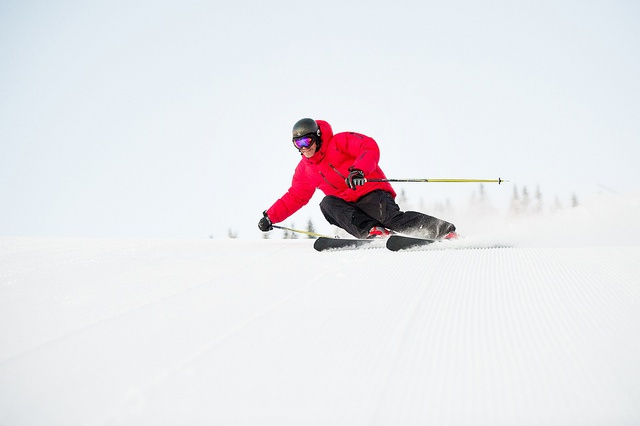Describe the objects in this image and their specific colors. I can see people in lightgray, black, red, and gray tones and skis in lightgray, gray, black, and darkgray tones in this image. 